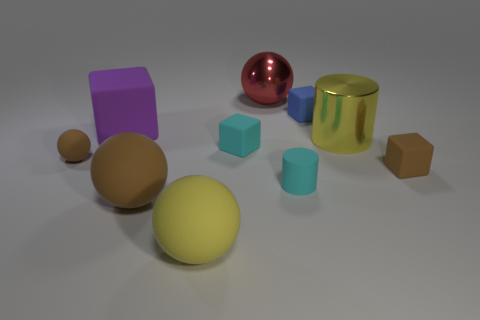There is a large metallic object right of the small blue rubber cube; is its color the same as the big object that is in front of the big brown object? The large metallic object to the right of the small blue cube is indeed red; notably, this is a reflective chrome-like hue. This color matches that of the large, shiny sphere that you see situated in front of the big brown cube, bringing a sense of visual harmony to the scene. 